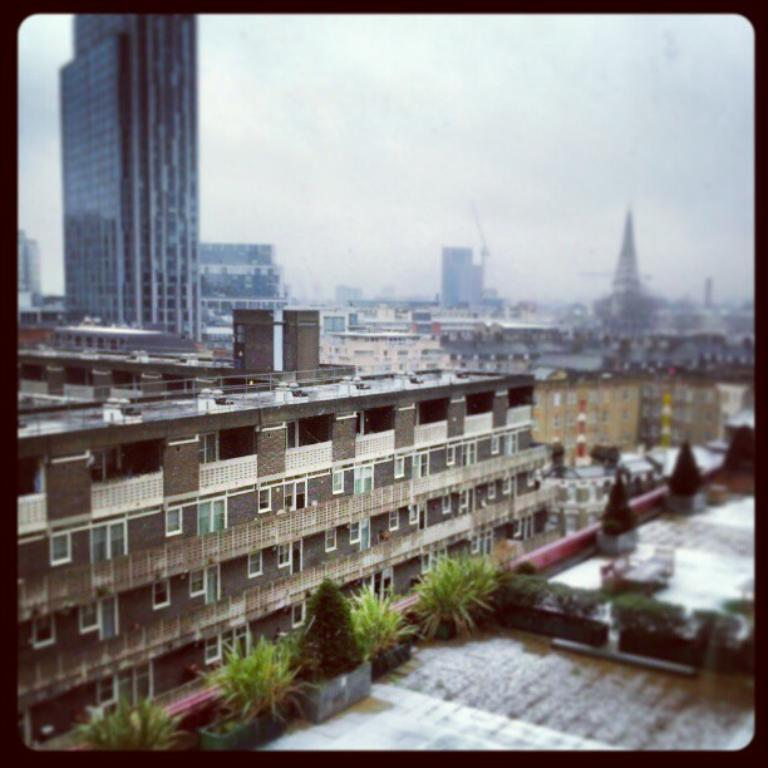What type of structures are present in the image? There are buildings with windows in the image. What other elements can be seen in the image besides the buildings? There are plants in the image. What part of the natural environment is visible in the image? The sky is visible in the image. What is the rate at which the plants are growing in the image? The rate at which the plants are growing cannot be determined from the image, as it only provides a snapshot of their current state. 